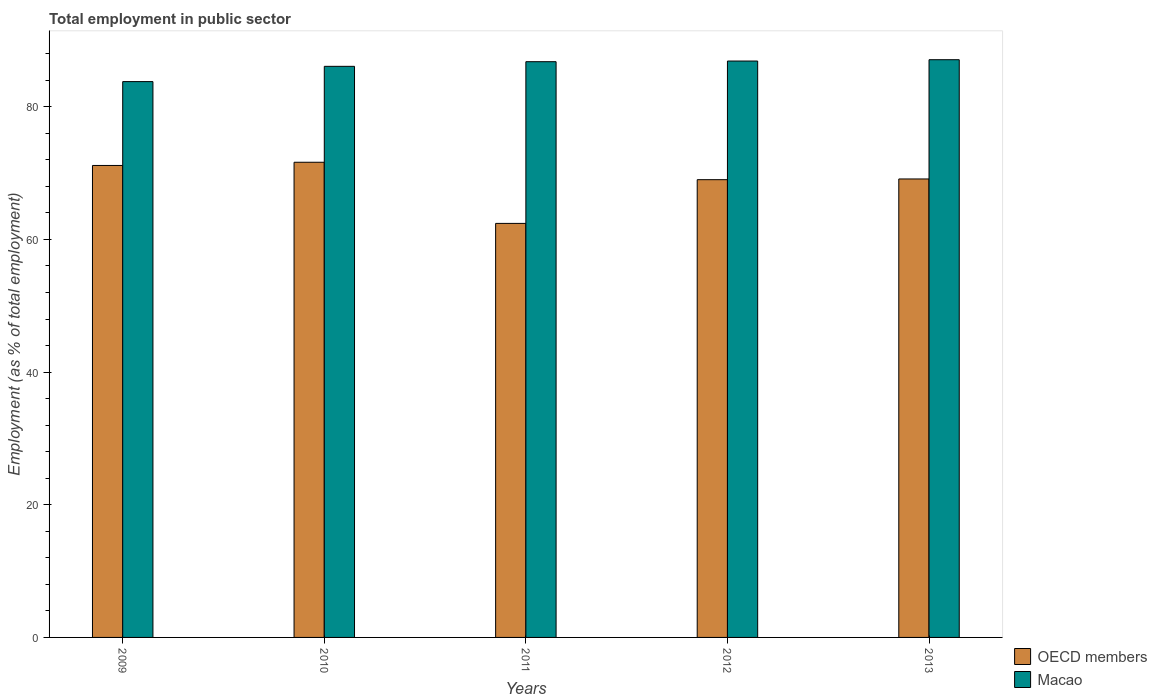How many bars are there on the 4th tick from the left?
Provide a short and direct response. 2. What is the label of the 2nd group of bars from the left?
Offer a terse response. 2010. What is the employment in public sector in Macao in 2009?
Give a very brief answer. 83.8. Across all years, what is the maximum employment in public sector in Macao?
Offer a terse response. 87.1. Across all years, what is the minimum employment in public sector in Macao?
Offer a very short reply. 83.8. In which year was the employment in public sector in OECD members minimum?
Give a very brief answer. 2011. What is the total employment in public sector in Macao in the graph?
Your answer should be very brief. 430.7. What is the difference between the employment in public sector in Macao in 2011 and that in 2013?
Give a very brief answer. -0.3. What is the difference between the employment in public sector in Macao in 2010 and the employment in public sector in OECD members in 2013?
Provide a short and direct response. 16.98. What is the average employment in public sector in OECD members per year?
Offer a terse response. 68.67. In the year 2010, what is the difference between the employment in public sector in OECD members and employment in public sector in Macao?
Offer a terse response. -14.46. What is the ratio of the employment in public sector in OECD members in 2010 to that in 2012?
Offer a very short reply. 1.04. Is the employment in public sector in Macao in 2011 less than that in 2012?
Ensure brevity in your answer.  Yes. Is the difference between the employment in public sector in OECD members in 2011 and 2012 greater than the difference between the employment in public sector in Macao in 2011 and 2012?
Provide a short and direct response. No. What is the difference between the highest and the second highest employment in public sector in OECD members?
Offer a terse response. 0.48. What is the difference between the highest and the lowest employment in public sector in Macao?
Your response must be concise. 3.3. In how many years, is the employment in public sector in OECD members greater than the average employment in public sector in OECD members taken over all years?
Make the answer very short. 4. Is the sum of the employment in public sector in Macao in 2009 and 2013 greater than the maximum employment in public sector in OECD members across all years?
Provide a succinct answer. Yes. What does the 1st bar from the left in 2009 represents?
Keep it short and to the point. OECD members. What does the 2nd bar from the right in 2009 represents?
Offer a terse response. OECD members. Are all the bars in the graph horizontal?
Your response must be concise. No. Are the values on the major ticks of Y-axis written in scientific E-notation?
Make the answer very short. No. Does the graph contain grids?
Provide a short and direct response. No. How many legend labels are there?
Give a very brief answer. 2. How are the legend labels stacked?
Provide a succinct answer. Vertical. What is the title of the graph?
Give a very brief answer. Total employment in public sector. What is the label or title of the X-axis?
Keep it short and to the point. Years. What is the label or title of the Y-axis?
Provide a short and direct response. Employment (as % of total employment). What is the Employment (as % of total employment) of OECD members in 2009?
Provide a short and direct response. 71.16. What is the Employment (as % of total employment) of Macao in 2009?
Offer a very short reply. 83.8. What is the Employment (as % of total employment) in OECD members in 2010?
Offer a very short reply. 71.64. What is the Employment (as % of total employment) in Macao in 2010?
Provide a short and direct response. 86.1. What is the Employment (as % of total employment) of OECD members in 2011?
Your response must be concise. 62.42. What is the Employment (as % of total employment) in Macao in 2011?
Give a very brief answer. 86.8. What is the Employment (as % of total employment) of OECD members in 2012?
Ensure brevity in your answer.  69.01. What is the Employment (as % of total employment) in Macao in 2012?
Your answer should be compact. 86.9. What is the Employment (as % of total employment) in OECD members in 2013?
Make the answer very short. 69.12. What is the Employment (as % of total employment) in Macao in 2013?
Provide a succinct answer. 87.1. Across all years, what is the maximum Employment (as % of total employment) of OECD members?
Your answer should be very brief. 71.64. Across all years, what is the maximum Employment (as % of total employment) of Macao?
Give a very brief answer. 87.1. Across all years, what is the minimum Employment (as % of total employment) in OECD members?
Offer a terse response. 62.42. Across all years, what is the minimum Employment (as % of total employment) in Macao?
Provide a succinct answer. 83.8. What is the total Employment (as % of total employment) of OECD members in the graph?
Give a very brief answer. 343.35. What is the total Employment (as % of total employment) in Macao in the graph?
Your response must be concise. 430.7. What is the difference between the Employment (as % of total employment) in OECD members in 2009 and that in 2010?
Provide a short and direct response. -0.48. What is the difference between the Employment (as % of total employment) of Macao in 2009 and that in 2010?
Ensure brevity in your answer.  -2.3. What is the difference between the Employment (as % of total employment) of OECD members in 2009 and that in 2011?
Provide a short and direct response. 8.73. What is the difference between the Employment (as % of total employment) of OECD members in 2009 and that in 2012?
Provide a succinct answer. 2.14. What is the difference between the Employment (as % of total employment) of Macao in 2009 and that in 2012?
Provide a succinct answer. -3.1. What is the difference between the Employment (as % of total employment) in OECD members in 2009 and that in 2013?
Keep it short and to the point. 2.04. What is the difference between the Employment (as % of total employment) in OECD members in 2010 and that in 2011?
Make the answer very short. 9.22. What is the difference between the Employment (as % of total employment) in OECD members in 2010 and that in 2012?
Provide a succinct answer. 2.63. What is the difference between the Employment (as % of total employment) of Macao in 2010 and that in 2012?
Your answer should be compact. -0.8. What is the difference between the Employment (as % of total employment) in OECD members in 2010 and that in 2013?
Provide a succinct answer. 2.52. What is the difference between the Employment (as % of total employment) in OECD members in 2011 and that in 2012?
Your answer should be very brief. -6.59. What is the difference between the Employment (as % of total employment) in OECD members in 2011 and that in 2013?
Provide a short and direct response. -6.7. What is the difference between the Employment (as % of total employment) of Macao in 2011 and that in 2013?
Offer a very short reply. -0.3. What is the difference between the Employment (as % of total employment) of OECD members in 2012 and that in 2013?
Provide a succinct answer. -0.11. What is the difference between the Employment (as % of total employment) of OECD members in 2009 and the Employment (as % of total employment) of Macao in 2010?
Give a very brief answer. -14.94. What is the difference between the Employment (as % of total employment) in OECD members in 2009 and the Employment (as % of total employment) in Macao in 2011?
Ensure brevity in your answer.  -15.64. What is the difference between the Employment (as % of total employment) in OECD members in 2009 and the Employment (as % of total employment) in Macao in 2012?
Give a very brief answer. -15.74. What is the difference between the Employment (as % of total employment) of OECD members in 2009 and the Employment (as % of total employment) of Macao in 2013?
Provide a short and direct response. -15.94. What is the difference between the Employment (as % of total employment) of OECD members in 2010 and the Employment (as % of total employment) of Macao in 2011?
Provide a short and direct response. -15.16. What is the difference between the Employment (as % of total employment) of OECD members in 2010 and the Employment (as % of total employment) of Macao in 2012?
Your response must be concise. -15.26. What is the difference between the Employment (as % of total employment) in OECD members in 2010 and the Employment (as % of total employment) in Macao in 2013?
Keep it short and to the point. -15.46. What is the difference between the Employment (as % of total employment) of OECD members in 2011 and the Employment (as % of total employment) of Macao in 2012?
Keep it short and to the point. -24.48. What is the difference between the Employment (as % of total employment) of OECD members in 2011 and the Employment (as % of total employment) of Macao in 2013?
Provide a succinct answer. -24.68. What is the difference between the Employment (as % of total employment) of OECD members in 2012 and the Employment (as % of total employment) of Macao in 2013?
Give a very brief answer. -18.09. What is the average Employment (as % of total employment) in OECD members per year?
Ensure brevity in your answer.  68.67. What is the average Employment (as % of total employment) of Macao per year?
Keep it short and to the point. 86.14. In the year 2009, what is the difference between the Employment (as % of total employment) of OECD members and Employment (as % of total employment) of Macao?
Make the answer very short. -12.64. In the year 2010, what is the difference between the Employment (as % of total employment) in OECD members and Employment (as % of total employment) in Macao?
Give a very brief answer. -14.46. In the year 2011, what is the difference between the Employment (as % of total employment) in OECD members and Employment (as % of total employment) in Macao?
Your answer should be compact. -24.38. In the year 2012, what is the difference between the Employment (as % of total employment) in OECD members and Employment (as % of total employment) in Macao?
Make the answer very short. -17.89. In the year 2013, what is the difference between the Employment (as % of total employment) in OECD members and Employment (as % of total employment) in Macao?
Your answer should be compact. -17.98. What is the ratio of the Employment (as % of total employment) of Macao in 2009 to that in 2010?
Give a very brief answer. 0.97. What is the ratio of the Employment (as % of total employment) of OECD members in 2009 to that in 2011?
Give a very brief answer. 1.14. What is the ratio of the Employment (as % of total employment) in Macao in 2009 to that in 2011?
Ensure brevity in your answer.  0.97. What is the ratio of the Employment (as % of total employment) of OECD members in 2009 to that in 2012?
Give a very brief answer. 1.03. What is the ratio of the Employment (as % of total employment) in OECD members in 2009 to that in 2013?
Offer a very short reply. 1.03. What is the ratio of the Employment (as % of total employment) in Macao in 2009 to that in 2013?
Offer a very short reply. 0.96. What is the ratio of the Employment (as % of total employment) in OECD members in 2010 to that in 2011?
Provide a short and direct response. 1.15. What is the ratio of the Employment (as % of total employment) in Macao in 2010 to that in 2011?
Ensure brevity in your answer.  0.99. What is the ratio of the Employment (as % of total employment) in OECD members in 2010 to that in 2012?
Keep it short and to the point. 1.04. What is the ratio of the Employment (as % of total employment) of OECD members in 2010 to that in 2013?
Give a very brief answer. 1.04. What is the ratio of the Employment (as % of total employment) of OECD members in 2011 to that in 2012?
Give a very brief answer. 0.9. What is the ratio of the Employment (as % of total employment) in OECD members in 2011 to that in 2013?
Provide a short and direct response. 0.9. What is the ratio of the Employment (as % of total employment) of OECD members in 2012 to that in 2013?
Your answer should be compact. 1. What is the difference between the highest and the second highest Employment (as % of total employment) of OECD members?
Give a very brief answer. 0.48. What is the difference between the highest and the second highest Employment (as % of total employment) in Macao?
Offer a very short reply. 0.2. What is the difference between the highest and the lowest Employment (as % of total employment) of OECD members?
Keep it short and to the point. 9.22. What is the difference between the highest and the lowest Employment (as % of total employment) of Macao?
Provide a succinct answer. 3.3. 